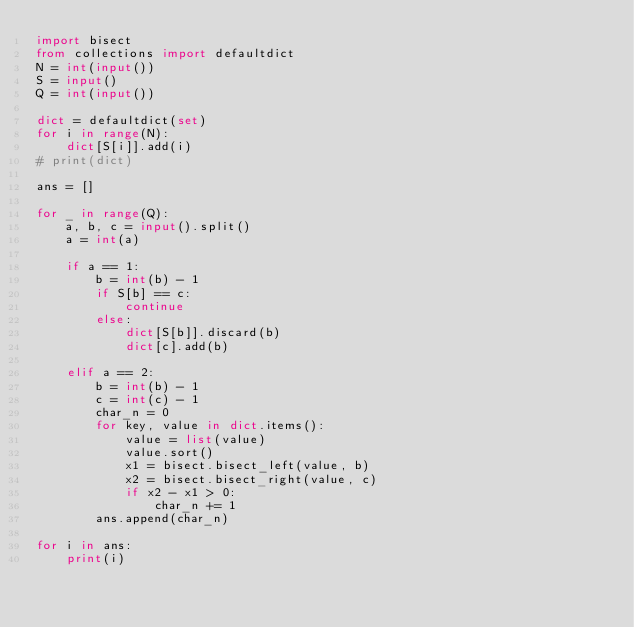<code> <loc_0><loc_0><loc_500><loc_500><_Python_>import bisect
from collections import defaultdict
N = int(input())
S = input()
Q = int(input())

dict = defaultdict(set)
for i in range(N):
    dict[S[i]].add(i)
# print(dict)

ans = []

for _ in range(Q):
    a, b, c = input().split()
    a = int(a)

    if a == 1:
        b = int(b) - 1
        if S[b] == c:
            continue
        else:
            dict[S[b]].discard(b)
            dict[c].add(b)

    elif a == 2:
        b = int(b) - 1
        c = int(c) - 1
        char_n = 0
        for key, value in dict.items():
            value = list(value)
            value.sort()
            x1 = bisect.bisect_left(value, b)
            x2 = bisect.bisect_right(value, c)
            if x2 - x1 > 0:
                char_n += 1
        ans.append(char_n)

for i in ans:
    print(i)
</code> 